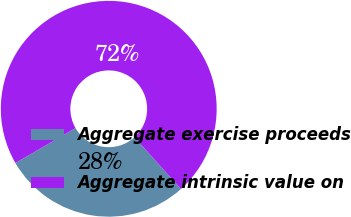Convert chart. <chart><loc_0><loc_0><loc_500><loc_500><pie_chart><fcel>Aggregate exercise proceeds<fcel>Aggregate intrinsic value on<nl><fcel>28.29%<fcel>71.71%<nl></chart> 